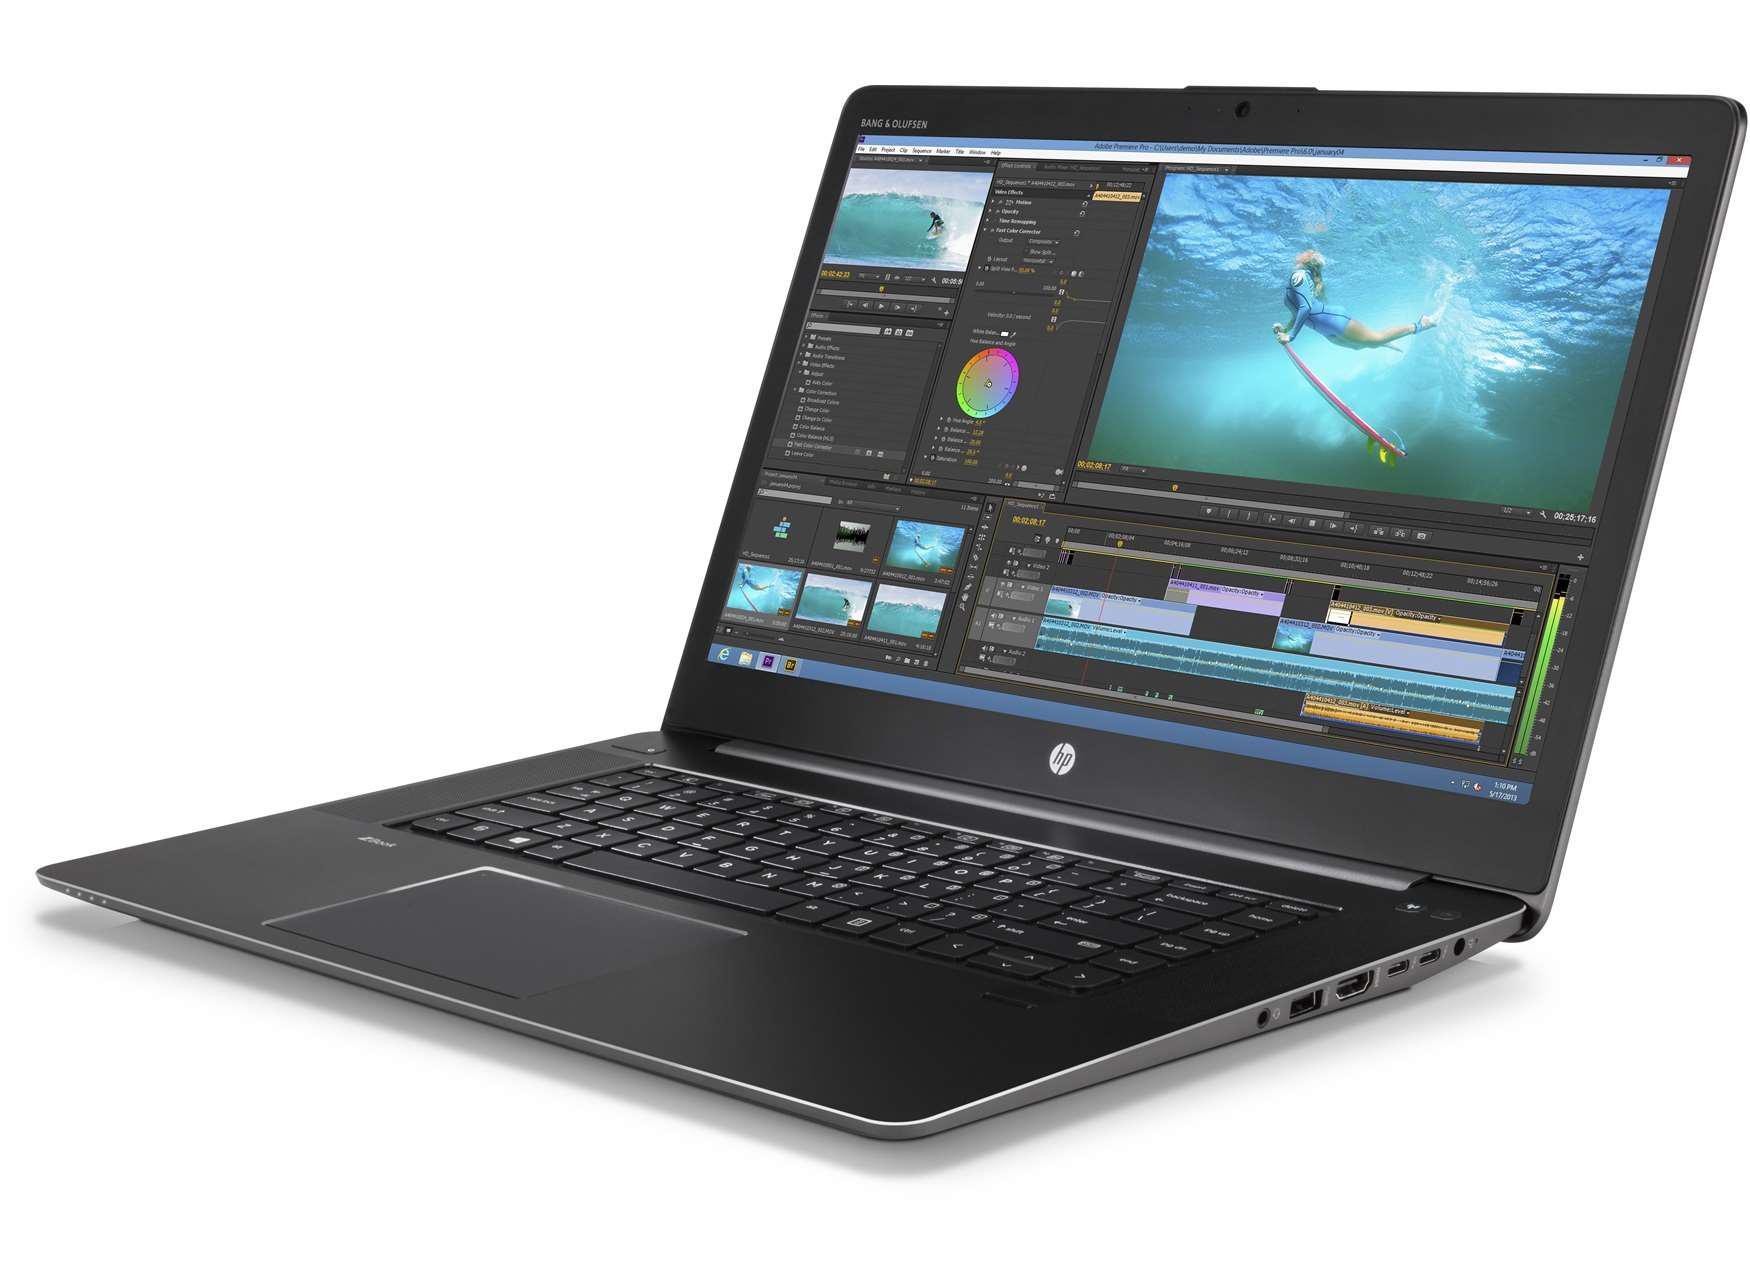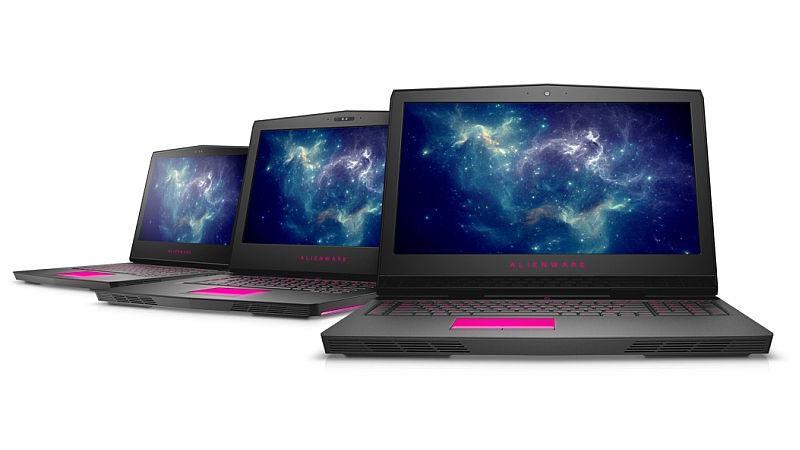The first image is the image on the left, the second image is the image on the right. Assess this claim about the two images: "Each image contains exactly one open laptop, and no laptop screen is disconnected from the base.". Correct or not? Answer yes or no. No. The first image is the image on the left, the second image is the image on the right. Evaluate the accuracy of this statement regarding the images: "One of the laptops has a blank screen.". Is it true? Answer yes or no. No. 